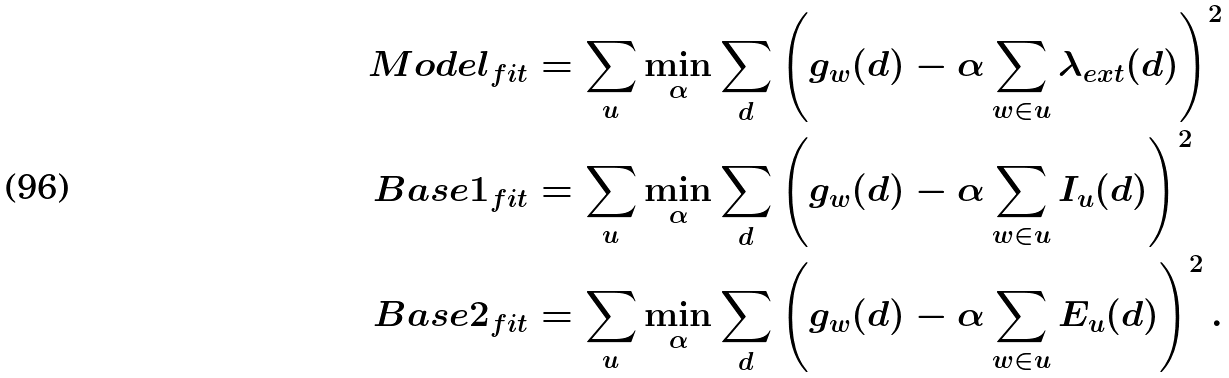<formula> <loc_0><loc_0><loc_500><loc_500>M o d e l _ { f i t } & = \sum _ { u } \min _ { \alpha } \sum _ { d } \left ( g _ { w } ( d ) - \alpha \sum _ { w \in u } \lambda _ { e x t } ( d ) \right ) ^ { 2 } \\ B a s e 1 _ { f i t } & = \sum _ { u } \min _ { \alpha } \sum _ { d } \left ( g _ { w } ( d ) - \alpha \sum _ { w \in u } I _ { u } ( d ) \right ) ^ { 2 } \\ B a s e 2 _ { f i t } & = \sum _ { u } \min _ { \alpha } \sum _ { d } \left ( g _ { w } ( d ) - \alpha \sum _ { w \in u } E _ { u } ( d ) \right ) ^ { 2 } . \\</formula> 